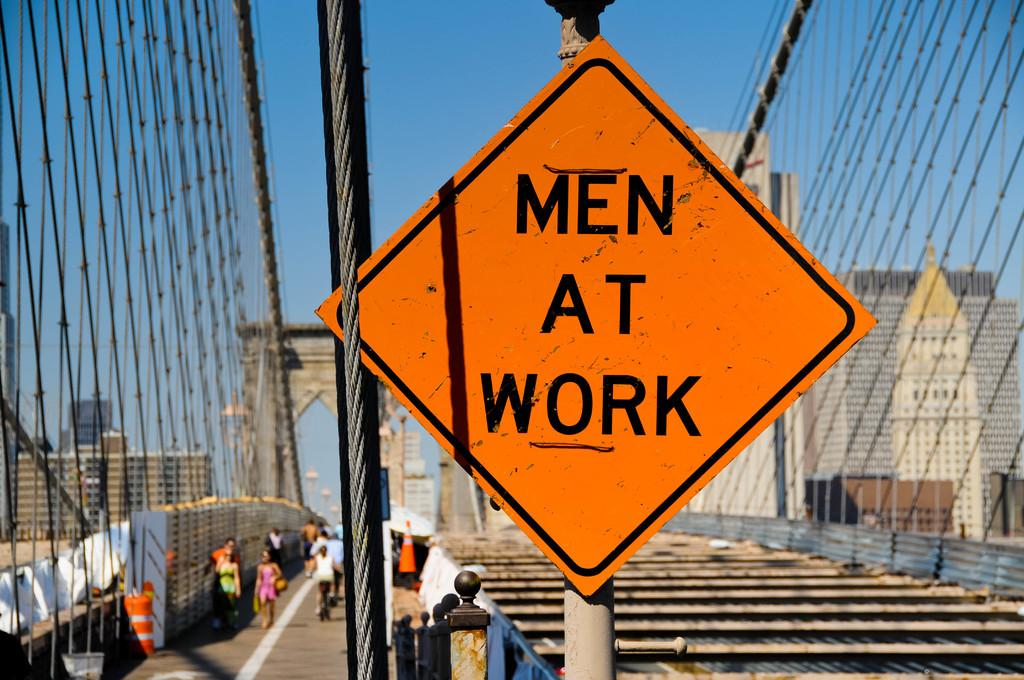<image>
Relay a brief, clear account of the picture shown. A sign in orange reading Men At Work. 